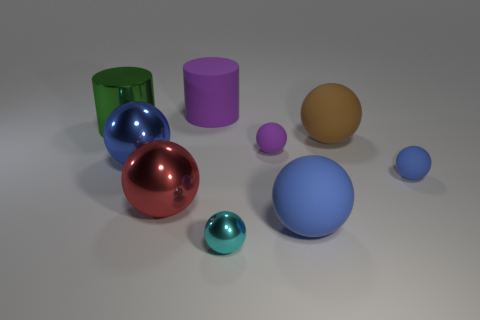There is a green cylinder that is the same size as the blue shiny sphere; what is its material?
Make the answer very short. Metal. There is a blue object on the left side of the small purple object; is its size the same as the matte sphere that is on the left side of the big blue rubber sphere?
Your answer should be compact. No. There is a large green object; are there any small metallic things to the left of it?
Your response must be concise. No. What color is the big rubber sphere behind the small rubber sphere that is behind the large blue metal object?
Provide a succinct answer. Brown. Is the number of big things less than the number of big red balls?
Your response must be concise. No. How many large blue objects are the same shape as the large brown object?
Your response must be concise. 2. There is a matte cylinder that is the same size as the red ball; what color is it?
Your response must be concise. Purple. Is the number of blue things that are in front of the big red metallic ball the same as the number of purple matte spheres behind the tiny shiny sphere?
Your answer should be compact. Yes. Are there any blue rubber balls of the same size as the green metal cylinder?
Make the answer very short. Yes. The purple matte sphere is what size?
Your response must be concise. Small. 